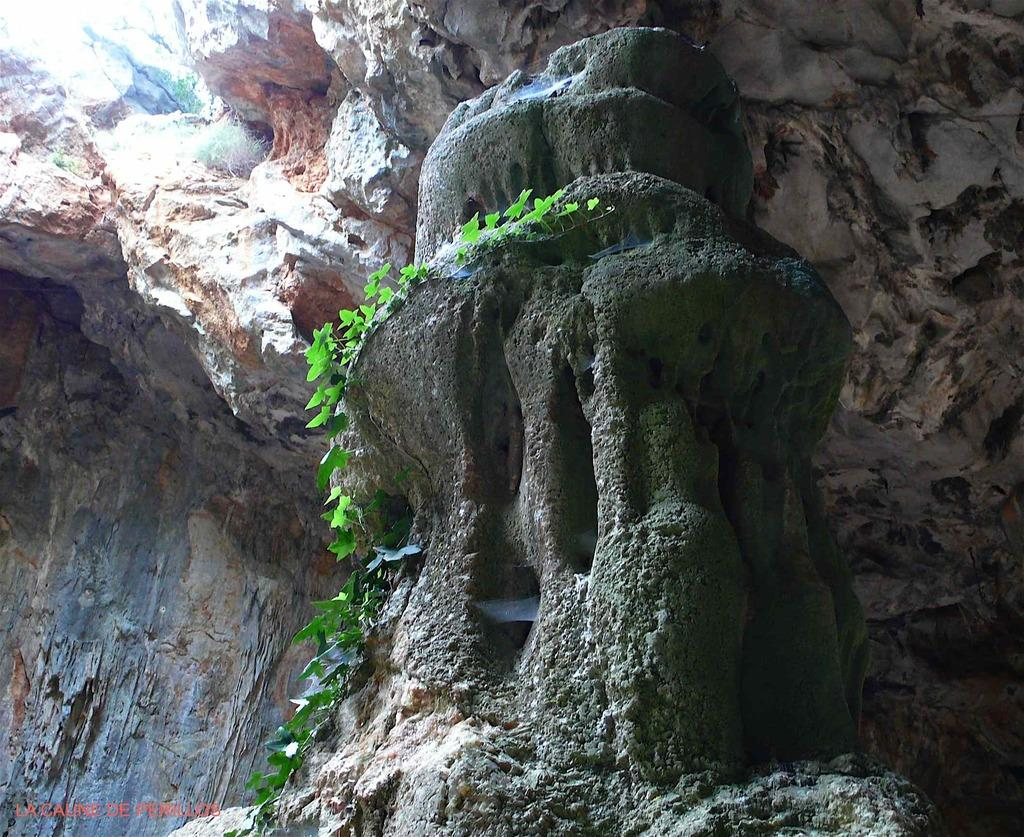What is located in the center of the image? There are green leaves and rocks in the center of the image. Can you describe the text in the image? The text is located in the bottom left corner of the image. How many girls are sitting in the lunchroom in the image? There are no girls or lunchroom present in the image. What type of coat is draped over the chair in the image? There is no coat or chair present in the image. 